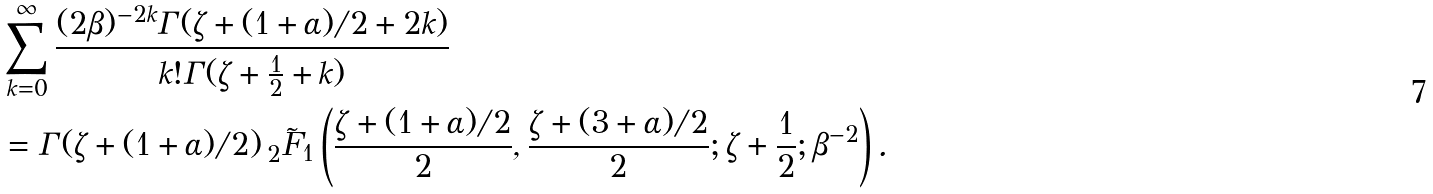<formula> <loc_0><loc_0><loc_500><loc_500>& \sum _ { k = 0 } ^ { \infty } \frac { ( 2 \beta ) ^ { - 2 k } \Gamma ( \zeta + ( 1 + \alpha ) / 2 + 2 k ) } { k ! \Gamma ( \zeta + \frac { 1 } { 2 } + k ) } \\ & = \Gamma ( \zeta + ( 1 + \alpha ) / 2 ) \, _ { 2 } \tilde { F } _ { 1 } \left ( \frac { \zeta + ( 1 + \alpha ) / 2 } { 2 } , \frac { \zeta + ( 3 + \alpha ) / 2 } { 2 } ; \zeta + \frac { 1 } { 2 } ; \beta ^ { - 2 } \right ) .</formula> 